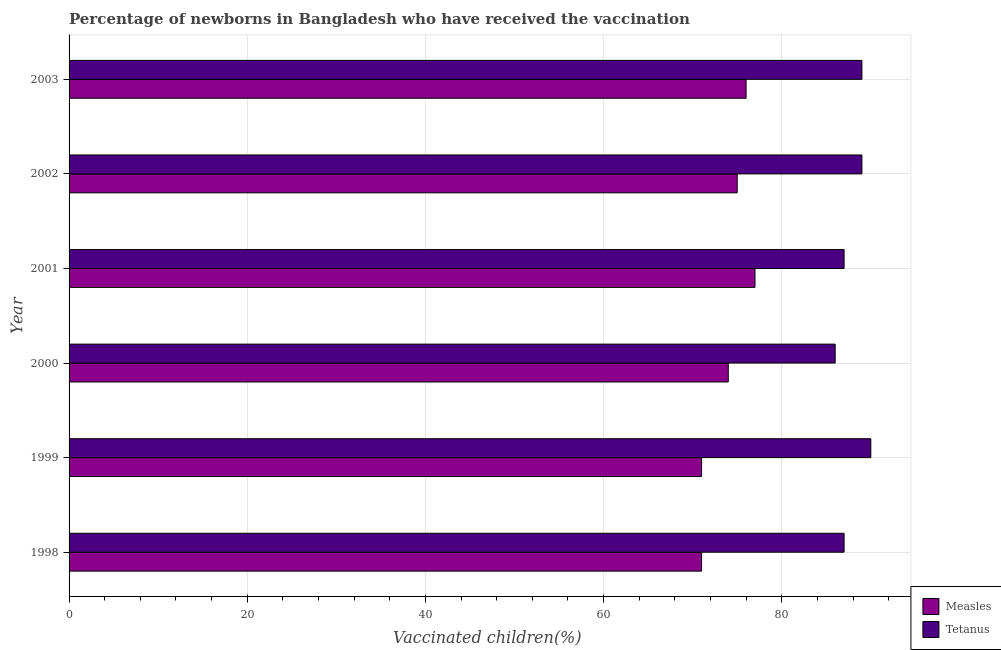Are the number of bars per tick equal to the number of legend labels?
Ensure brevity in your answer.  Yes. What is the label of the 1st group of bars from the top?
Your answer should be compact. 2003. In how many cases, is the number of bars for a given year not equal to the number of legend labels?
Your response must be concise. 0. What is the percentage of newborns who received vaccination for tetanus in 2003?
Provide a succinct answer. 89. Across all years, what is the maximum percentage of newborns who received vaccination for measles?
Make the answer very short. 77. Across all years, what is the minimum percentage of newborns who received vaccination for measles?
Offer a terse response. 71. In which year was the percentage of newborns who received vaccination for measles maximum?
Keep it short and to the point. 2001. What is the total percentage of newborns who received vaccination for tetanus in the graph?
Ensure brevity in your answer.  528. What is the difference between the percentage of newborns who received vaccination for measles in 1999 and that in 2001?
Make the answer very short. -6. What is the difference between the percentage of newborns who received vaccination for measles in 2002 and the percentage of newborns who received vaccination for tetanus in 2000?
Offer a terse response. -11. What is the average percentage of newborns who received vaccination for measles per year?
Give a very brief answer. 74. In the year 2000, what is the difference between the percentage of newborns who received vaccination for measles and percentage of newborns who received vaccination for tetanus?
Provide a succinct answer. -12. Is the percentage of newborns who received vaccination for measles in 2001 less than that in 2002?
Provide a short and direct response. No. Is the sum of the percentage of newborns who received vaccination for tetanus in 2001 and 2003 greater than the maximum percentage of newborns who received vaccination for measles across all years?
Your response must be concise. Yes. What does the 1st bar from the top in 2000 represents?
Offer a terse response. Tetanus. What does the 1st bar from the bottom in 2001 represents?
Keep it short and to the point. Measles. How many bars are there?
Give a very brief answer. 12. What is the difference between two consecutive major ticks on the X-axis?
Give a very brief answer. 20. Are the values on the major ticks of X-axis written in scientific E-notation?
Provide a succinct answer. No. Does the graph contain any zero values?
Give a very brief answer. No. Does the graph contain grids?
Offer a terse response. Yes. Where does the legend appear in the graph?
Ensure brevity in your answer.  Bottom right. How many legend labels are there?
Provide a short and direct response. 2. How are the legend labels stacked?
Provide a succinct answer. Vertical. What is the title of the graph?
Keep it short and to the point. Percentage of newborns in Bangladesh who have received the vaccination. What is the label or title of the X-axis?
Make the answer very short. Vaccinated children(%)
. What is the label or title of the Y-axis?
Ensure brevity in your answer.  Year. What is the Vaccinated children(%)
 of Measles in 1998?
Ensure brevity in your answer.  71. What is the Vaccinated children(%)
 in Tetanus in 1998?
Provide a succinct answer. 87. What is the Vaccinated children(%)
 of Tetanus in 1999?
Provide a short and direct response. 90. What is the Vaccinated children(%)
 in Measles in 2001?
Ensure brevity in your answer.  77. What is the Vaccinated children(%)
 in Tetanus in 2002?
Provide a succinct answer. 89. What is the Vaccinated children(%)
 of Measles in 2003?
Provide a short and direct response. 76. What is the Vaccinated children(%)
 of Tetanus in 2003?
Ensure brevity in your answer.  89. Across all years, what is the maximum Vaccinated children(%)
 of Tetanus?
Your answer should be compact. 90. What is the total Vaccinated children(%)
 in Measles in the graph?
Offer a very short reply. 444. What is the total Vaccinated children(%)
 in Tetanus in the graph?
Offer a terse response. 528. What is the difference between the Vaccinated children(%)
 in Measles in 1998 and that in 1999?
Keep it short and to the point. 0. What is the difference between the Vaccinated children(%)
 in Tetanus in 1998 and that in 1999?
Give a very brief answer. -3. What is the difference between the Vaccinated children(%)
 of Measles in 1998 and that in 2000?
Provide a succinct answer. -3. What is the difference between the Vaccinated children(%)
 in Tetanus in 1998 and that in 2000?
Your response must be concise. 1. What is the difference between the Vaccinated children(%)
 in Measles in 1998 and that in 2001?
Your answer should be compact. -6. What is the difference between the Vaccinated children(%)
 in Measles in 1998 and that in 2002?
Offer a very short reply. -4. What is the difference between the Vaccinated children(%)
 in Measles in 1999 and that in 2000?
Your answer should be compact. -3. What is the difference between the Vaccinated children(%)
 of Measles in 1999 and that in 2002?
Your answer should be compact. -4. What is the difference between the Vaccinated children(%)
 in Measles in 1999 and that in 2003?
Ensure brevity in your answer.  -5. What is the difference between the Vaccinated children(%)
 in Tetanus in 1999 and that in 2003?
Offer a terse response. 1. What is the difference between the Vaccinated children(%)
 of Measles in 2000 and that in 2002?
Offer a very short reply. -1. What is the difference between the Vaccinated children(%)
 in Tetanus in 2000 and that in 2002?
Offer a very short reply. -3. What is the difference between the Vaccinated children(%)
 of Tetanus in 2000 and that in 2003?
Ensure brevity in your answer.  -3. What is the difference between the Vaccinated children(%)
 in Tetanus in 2001 and that in 2002?
Keep it short and to the point. -2. What is the difference between the Vaccinated children(%)
 in Tetanus in 2002 and that in 2003?
Give a very brief answer. 0. What is the difference between the Vaccinated children(%)
 in Measles in 1998 and the Vaccinated children(%)
 in Tetanus in 1999?
Keep it short and to the point. -19. What is the difference between the Vaccinated children(%)
 in Measles in 1998 and the Vaccinated children(%)
 in Tetanus in 2001?
Provide a short and direct response. -16. What is the difference between the Vaccinated children(%)
 of Measles in 1998 and the Vaccinated children(%)
 of Tetanus in 2002?
Provide a succinct answer. -18. What is the difference between the Vaccinated children(%)
 in Measles in 1998 and the Vaccinated children(%)
 in Tetanus in 2003?
Your answer should be very brief. -18. What is the difference between the Vaccinated children(%)
 in Measles in 1999 and the Vaccinated children(%)
 in Tetanus in 2002?
Your answer should be very brief. -18. What is the difference between the Vaccinated children(%)
 of Measles in 1999 and the Vaccinated children(%)
 of Tetanus in 2003?
Your answer should be very brief. -18. What is the difference between the Vaccinated children(%)
 in Measles in 2001 and the Vaccinated children(%)
 in Tetanus in 2003?
Your response must be concise. -12. What is the average Vaccinated children(%)
 of Measles per year?
Keep it short and to the point. 74. In the year 2001, what is the difference between the Vaccinated children(%)
 of Measles and Vaccinated children(%)
 of Tetanus?
Offer a terse response. -10. In the year 2003, what is the difference between the Vaccinated children(%)
 of Measles and Vaccinated children(%)
 of Tetanus?
Make the answer very short. -13. What is the ratio of the Vaccinated children(%)
 of Tetanus in 1998 to that in 1999?
Your answer should be compact. 0.97. What is the ratio of the Vaccinated children(%)
 of Measles in 1998 to that in 2000?
Ensure brevity in your answer.  0.96. What is the ratio of the Vaccinated children(%)
 of Tetanus in 1998 to that in 2000?
Ensure brevity in your answer.  1.01. What is the ratio of the Vaccinated children(%)
 of Measles in 1998 to that in 2001?
Your answer should be compact. 0.92. What is the ratio of the Vaccinated children(%)
 in Measles in 1998 to that in 2002?
Make the answer very short. 0.95. What is the ratio of the Vaccinated children(%)
 in Tetanus in 1998 to that in 2002?
Provide a short and direct response. 0.98. What is the ratio of the Vaccinated children(%)
 in Measles in 1998 to that in 2003?
Your answer should be very brief. 0.93. What is the ratio of the Vaccinated children(%)
 in Tetanus in 1998 to that in 2003?
Provide a short and direct response. 0.98. What is the ratio of the Vaccinated children(%)
 in Measles in 1999 to that in 2000?
Your answer should be compact. 0.96. What is the ratio of the Vaccinated children(%)
 in Tetanus in 1999 to that in 2000?
Offer a very short reply. 1.05. What is the ratio of the Vaccinated children(%)
 of Measles in 1999 to that in 2001?
Your response must be concise. 0.92. What is the ratio of the Vaccinated children(%)
 in Tetanus in 1999 to that in 2001?
Ensure brevity in your answer.  1.03. What is the ratio of the Vaccinated children(%)
 of Measles in 1999 to that in 2002?
Your response must be concise. 0.95. What is the ratio of the Vaccinated children(%)
 in Tetanus in 1999 to that in 2002?
Make the answer very short. 1.01. What is the ratio of the Vaccinated children(%)
 of Measles in 1999 to that in 2003?
Provide a succinct answer. 0.93. What is the ratio of the Vaccinated children(%)
 in Tetanus in 1999 to that in 2003?
Offer a very short reply. 1.01. What is the ratio of the Vaccinated children(%)
 of Measles in 2000 to that in 2001?
Ensure brevity in your answer.  0.96. What is the ratio of the Vaccinated children(%)
 in Tetanus in 2000 to that in 2001?
Your answer should be very brief. 0.99. What is the ratio of the Vaccinated children(%)
 of Measles in 2000 to that in 2002?
Offer a very short reply. 0.99. What is the ratio of the Vaccinated children(%)
 of Tetanus in 2000 to that in 2002?
Provide a succinct answer. 0.97. What is the ratio of the Vaccinated children(%)
 in Measles in 2000 to that in 2003?
Make the answer very short. 0.97. What is the ratio of the Vaccinated children(%)
 of Tetanus in 2000 to that in 2003?
Offer a very short reply. 0.97. What is the ratio of the Vaccinated children(%)
 of Measles in 2001 to that in 2002?
Provide a succinct answer. 1.03. What is the ratio of the Vaccinated children(%)
 of Tetanus in 2001 to that in 2002?
Ensure brevity in your answer.  0.98. What is the ratio of the Vaccinated children(%)
 of Measles in 2001 to that in 2003?
Give a very brief answer. 1.01. What is the ratio of the Vaccinated children(%)
 of Tetanus in 2001 to that in 2003?
Your answer should be compact. 0.98. What is the ratio of the Vaccinated children(%)
 in Measles in 2002 to that in 2003?
Your response must be concise. 0.99. What is the ratio of the Vaccinated children(%)
 of Tetanus in 2002 to that in 2003?
Your response must be concise. 1. What is the difference between the highest and the lowest Vaccinated children(%)
 in Tetanus?
Your response must be concise. 4. 